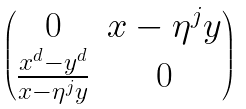Convert formula to latex. <formula><loc_0><loc_0><loc_500><loc_500>\begin{pmatrix} 0 & x - \eta ^ { j } y \\ \frac { x ^ { d } - y ^ { d } } { x - \eta ^ { j } y } & 0 \end{pmatrix}</formula> 